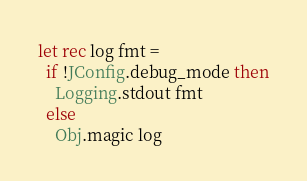Convert code to text. <code><loc_0><loc_0><loc_500><loc_500><_OCaml_>

let rec log fmt =
  if !JConfig.debug_mode then
    Logging.stdout fmt
  else
    Obj.magic log
</code> 